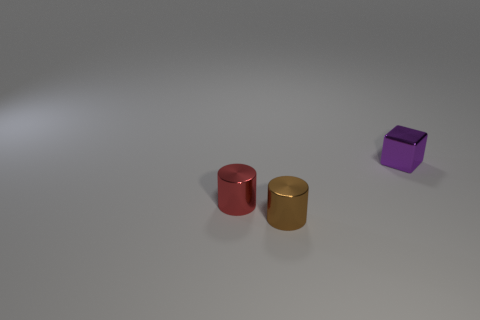Add 2 brown shiny objects. How many objects exist? 5 Subtract all cylinders. How many objects are left? 1 Add 2 small shiny things. How many small shiny things are left? 5 Add 3 large purple balls. How many large purple balls exist? 3 Subtract 0 blue cylinders. How many objects are left? 3 Subtract all purple objects. Subtract all small rubber blocks. How many objects are left? 2 